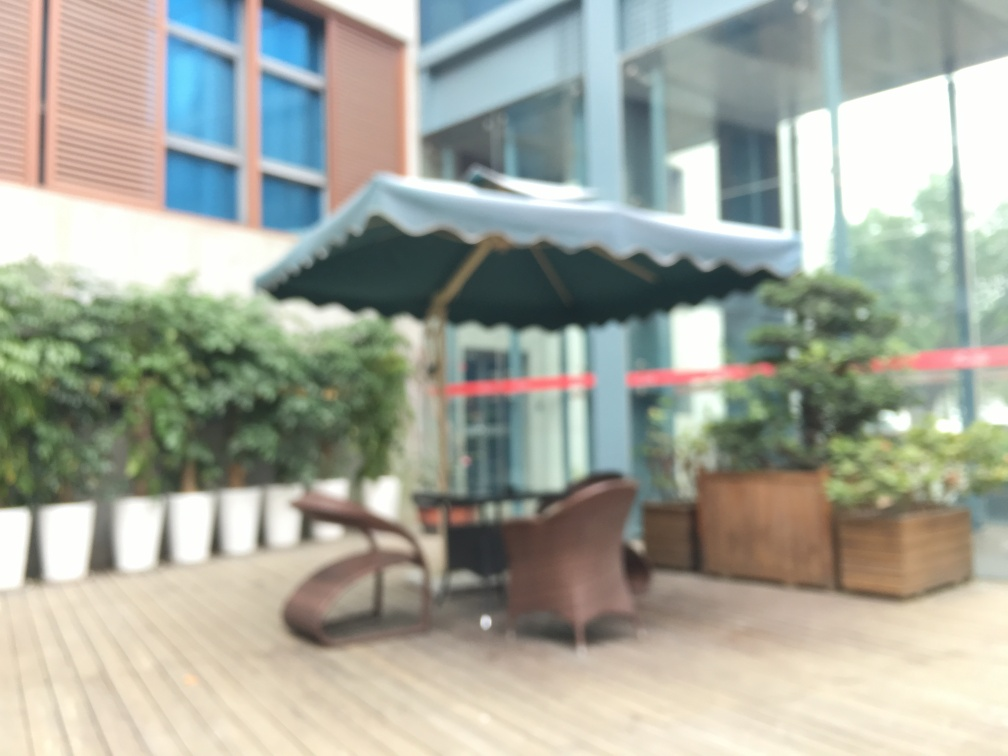Can you describe the weather or time of day this photo might have been taken? The brightness and shadows in the image suggest that it was taken during daylight, possibly midday. The sky seems overcast, indicating that the weather might be cloudy. 